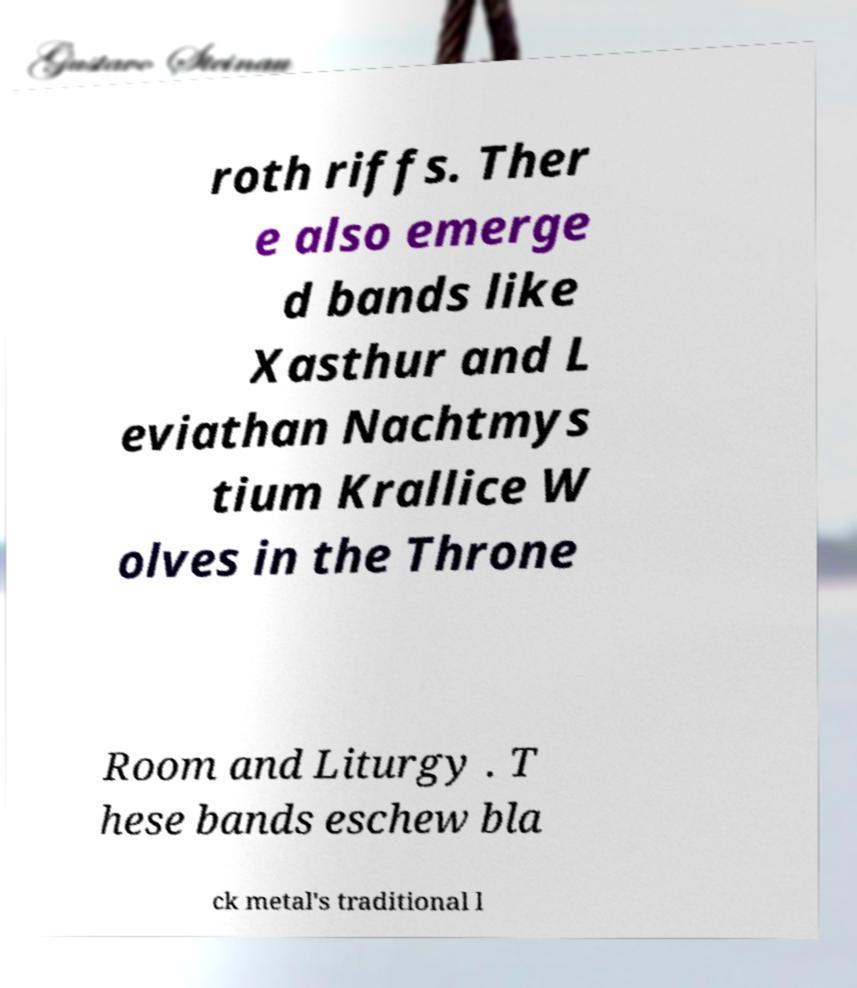Please read and relay the text visible in this image. What does it say? roth riffs. Ther e also emerge d bands like Xasthur and L eviathan Nachtmys tium Krallice W olves in the Throne Room and Liturgy . T hese bands eschew bla ck metal's traditional l 